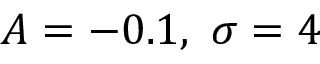<formula> <loc_0><loc_0><loc_500><loc_500>A = - 0 . 1 , \ \sigma = 4</formula> 